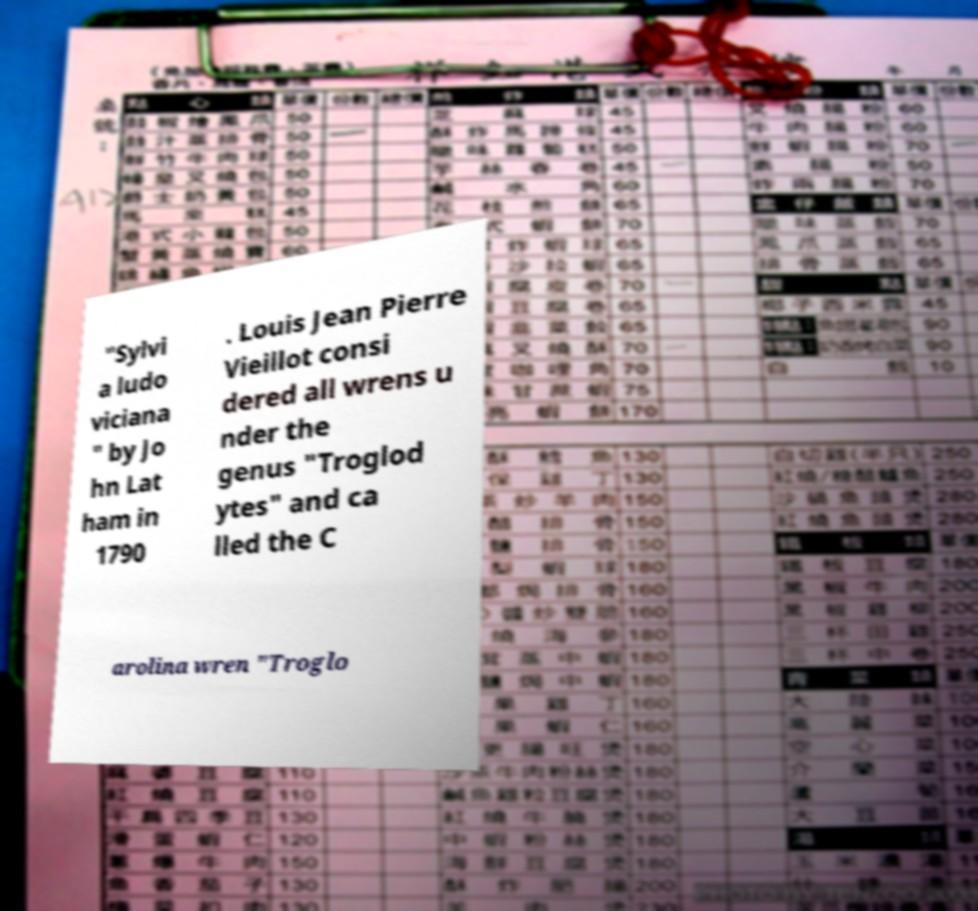Could you assist in decoding the text presented in this image and type it out clearly? "Sylvi a ludo viciana " by Jo hn Lat ham in 1790 . Louis Jean Pierre Vieillot consi dered all wrens u nder the genus "Troglod ytes" and ca lled the C arolina wren "Troglo 